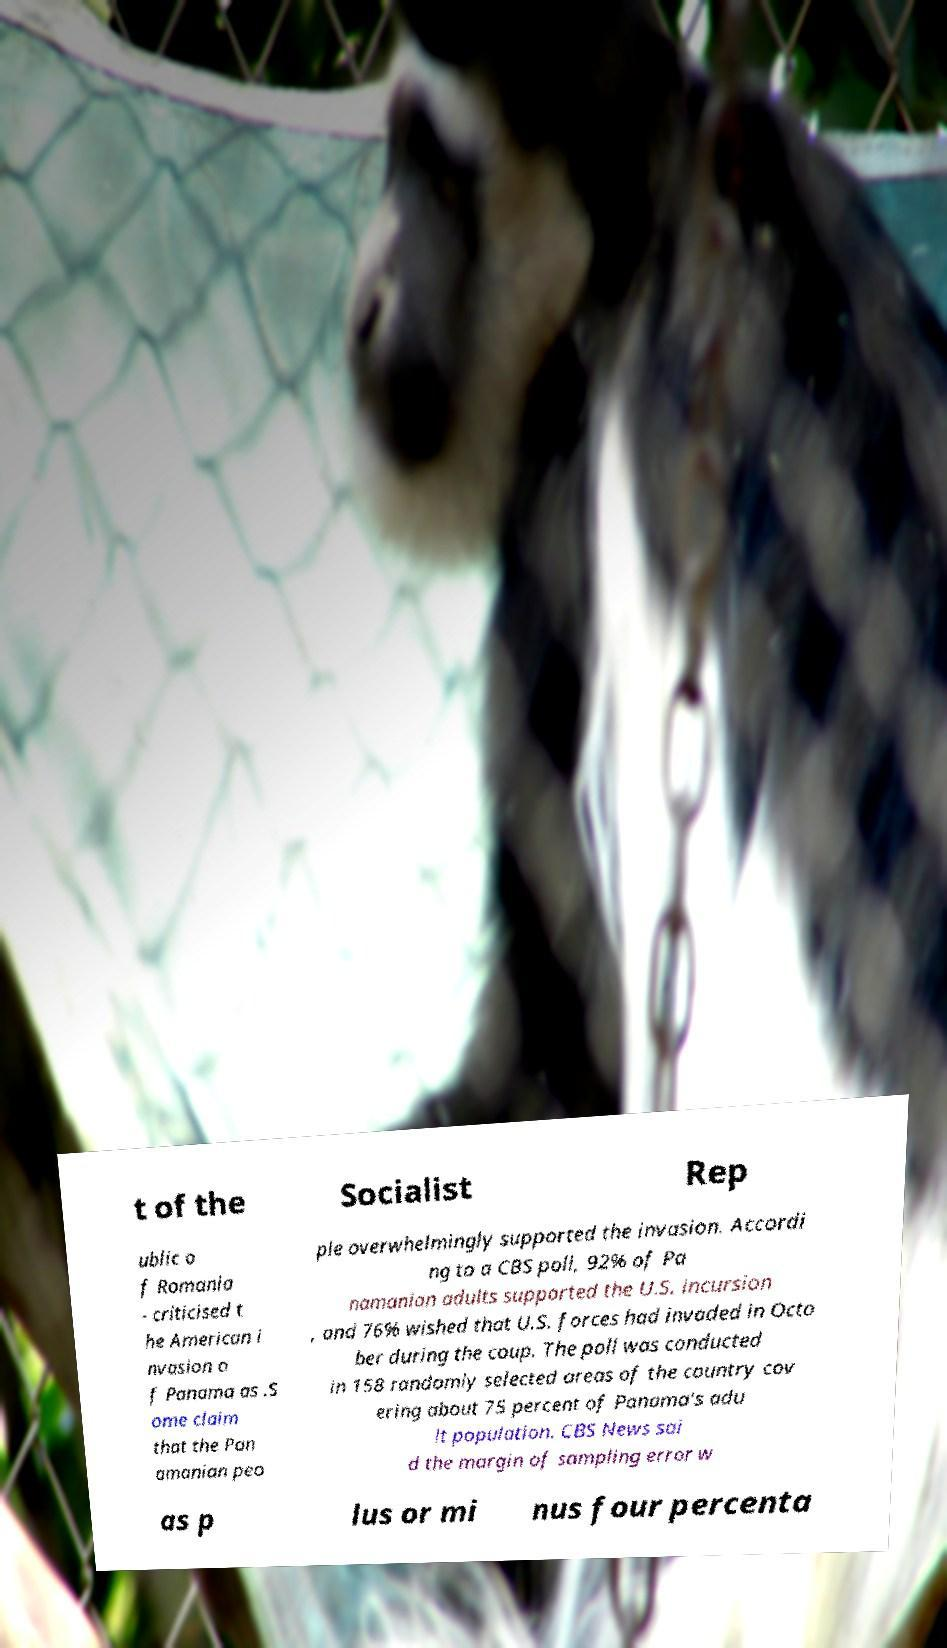Please identify and transcribe the text found in this image. t of the Socialist Rep ublic o f Romania - criticised t he American i nvasion o f Panama as .S ome claim that the Pan amanian peo ple overwhelmingly supported the invasion. Accordi ng to a CBS poll, 92% of Pa namanian adults supported the U.S. incursion , and 76% wished that U.S. forces had invaded in Octo ber during the coup. The poll was conducted in 158 randomly selected areas of the country cov ering about 75 percent of Panama's adu lt population. CBS News sai d the margin of sampling error w as p lus or mi nus four percenta 